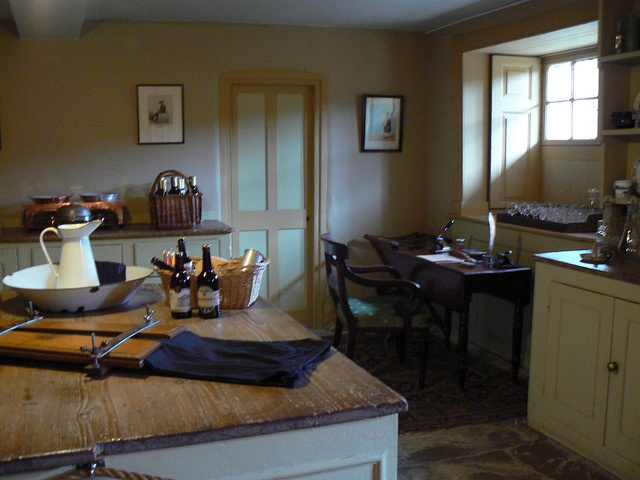Describe the objects in this image and their specific colors. I can see dining table in black, gray, and navy tones, chair in black, teal, and gray tones, bowl in black, gray, lightblue, and darkgray tones, bottle in black, gray, and olive tones, and bottle in black, gray, and maroon tones in this image. 